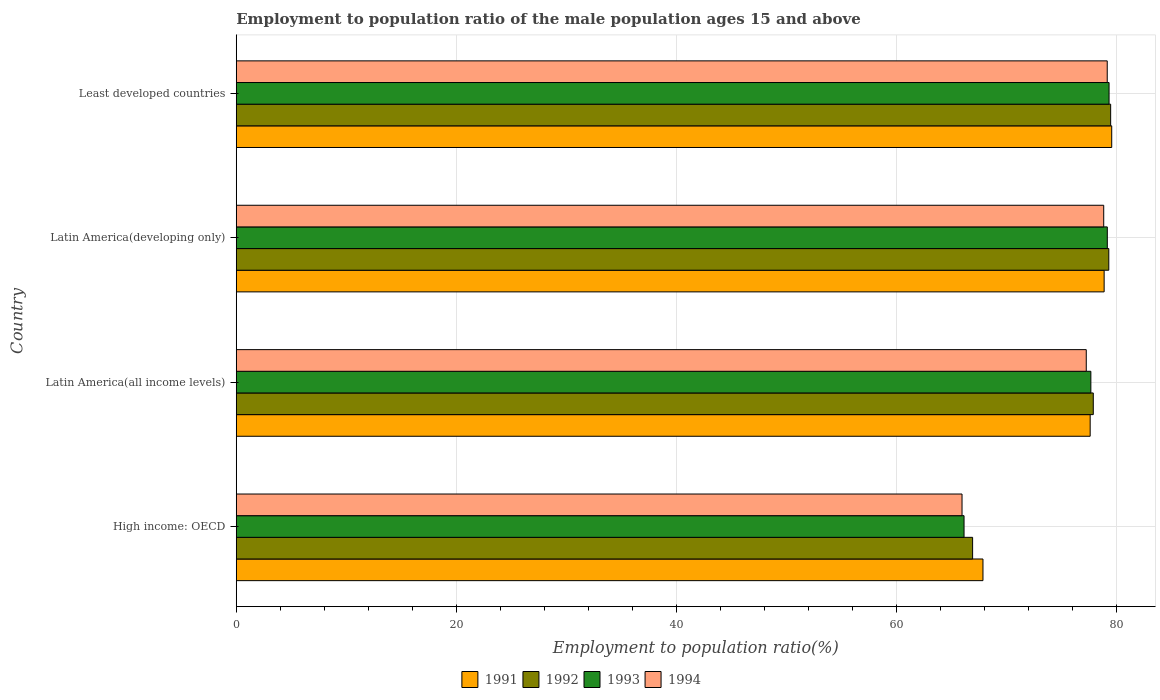How many different coloured bars are there?
Offer a very short reply. 4. How many groups of bars are there?
Ensure brevity in your answer.  4. Are the number of bars per tick equal to the number of legend labels?
Give a very brief answer. Yes. Are the number of bars on each tick of the Y-axis equal?
Provide a succinct answer. Yes. What is the label of the 1st group of bars from the top?
Offer a terse response. Least developed countries. In how many cases, is the number of bars for a given country not equal to the number of legend labels?
Keep it short and to the point. 0. What is the employment to population ratio in 1991 in Latin America(developing only)?
Provide a succinct answer. 78.9. Across all countries, what is the maximum employment to population ratio in 1994?
Offer a very short reply. 79.18. Across all countries, what is the minimum employment to population ratio in 1991?
Your answer should be compact. 67.88. In which country was the employment to population ratio in 1994 maximum?
Offer a very short reply. Least developed countries. In which country was the employment to population ratio in 1994 minimum?
Provide a short and direct response. High income: OECD. What is the total employment to population ratio in 1992 in the graph?
Offer a terse response. 303.66. What is the difference between the employment to population ratio in 1994 in Latin America(developing only) and that in Least developed countries?
Ensure brevity in your answer.  -0.32. What is the difference between the employment to population ratio in 1994 in Latin America(developing only) and the employment to population ratio in 1992 in Least developed countries?
Your answer should be compact. -0.63. What is the average employment to population ratio in 1992 per country?
Provide a short and direct response. 75.92. What is the difference between the employment to population ratio in 1994 and employment to population ratio in 1991 in Least developed countries?
Offer a terse response. -0.41. In how many countries, is the employment to population ratio in 1992 greater than 20 %?
Your answer should be very brief. 4. What is the ratio of the employment to population ratio in 1994 in Latin America(all income levels) to that in Least developed countries?
Ensure brevity in your answer.  0.98. Is the difference between the employment to population ratio in 1994 in Latin America(all income levels) and Latin America(developing only) greater than the difference between the employment to population ratio in 1991 in Latin America(all income levels) and Latin America(developing only)?
Provide a short and direct response. No. What is the difference between the highest and the second highest employment to population ratio in 1991?
Your answer should be very brief. 0.69. What is the difference between the highest and the lowest employment to population ratio in 1992?
Provide a short and direct response. 12.55. In how many countries, is the employment to population ratio in 1991 greater than the average employment to population ratio in 1991 taken over all countries?
Ensure brevity in your answer.  3. Is the sum of the employment to population ratio in 1993 in Latin America(all income levels) and Latin America(developing only) greater than the maximum employment to population ratio in 1991 across all countries?
Your answer should be compact. Yes. What does the 1st bar from the bottom in Latin America(all income levels) represents?
Make the answer very short. 1991. Is it the case that in every country, the sum of the employment to population ratio in 1992 and employment to population ratio in 1993 is greater than the employment to population ratio in 1994?
Give a very brief answer. Yes. How many bars are there?
Give a very brief answer. 16. Are all the bars in the graph horizontal?
Provide a short and direct response. Yes. How many countries are there in the graph?
Give a very brief answer. 4. Does the graph contain any zero values?
Give a very brief answer. No. Does the graph contain grids?
Your answer should be compact. Yes. Where does the legend appear in the graph?
Make the answer very short. Bottom center. How are the legend labels stacked?
Ensure brevity in your answer.  Horizontal. What is the title of the graph?
Offer a very short reply. Employment to population ratio of the male population ages 15 and above. What is the label or title of the X-axis?
Your answer should be very brief. Employment to population ratio(%). What is the label or title of the Y-axis?
Your answer should be compact. Country. What is the Employment to population ratio(%) in 1991 in High income: OECD?
Ensure brevity in your answer.  67.88. What is the Employment to population ratio(%) of 1992 in High income: OECD?
Keep it short and to the point. 66.94. What is the Employment to population ratio(%) in 1993 in High income: OECD?
Your answer should be very brief. 66.16. What is the Employment to population ratio(%) of 1994 in High income: OECD?
Provide a succinct answer. 65.98. What is the Employment to population ratio(%) of 1991 in Latin America(all income levels)?
Provide a short and direct response. 77.63. What is the Employment to population ratio(%) of 1992 in Latin America(all income levels)?
Your response must be concise. 77.91. What is the Employment to population ratio(%) in 1993 in Latin America(all income levels)?
Ensure brevity in your answer.  77.69. What is the Employment to population ratio(%) in 1994 in Latin America(all income levels)?
Provide a short and direct response. 77.27. What is the Employment to population ratio(%) in 1991 in Latin America(developing only)?
Your answer should be very brief. 78.9. What is the Employment to population ratio(%) of 1992 in Latin America(developing only)?
Provide a succinct answer. 79.32. What is the Employment to population ratio(%) in 1993 in Latin America(developing only)?
Make the answer very short. 79.19. What is the Employment to population ratio(%) of 1994 in Latin America(developing only)?
Ensure brevity in your answer.  78.86. What is the Employment to population ratio(%) of 1991 in Least developed countries?
Keep it short and to the point. 79.59. What is the Employment to population ratio(%) in 1992 in Least developed countries?
Your answer should be very brief. 79.49. What is the Employment to population ratio(%) of 1993 in Least developed countries?
Your response must be concise. 79.34. What is the Employment to population ratio(%) of 1994 in Least developed countries?
Your response must be concise. 79.18. Across all countries, what is the maximum Employment to population ratio(%) of 1991?
Your response must be concise. 79.59. Across all countries, what is the maximum Employment to population ratio(%) of 1992?
Ensure brevity in your answer.  79.49. Across all countries, what is the maximum Employment to population ratio(%) in 1993?
Provide a succinct answer. 79.34. Across all countries, what is the maximum Employment to population ratio(%) of 1994?
Provide a short and direct response. 79.18. Across all countries, what is the minimum Employment to population ratio(%) in 1991?
Your answer should be compact. 67.88. Across all countries, what is the minimum Employment to population ratio(%) of 1992?
Offer a very short reply. 66.94. Across all countries, what is the minimum Employment to population ratio(%) in 1993?
Provide a short and direct response. 66.16. Across all countries, what is the minimum Employment to population ratio(%) of 1994?
Your response must be concise. 65.98. What is the total Employment to population ratio(%) of 1991 in the graph?
Give a very brief answer. 303.99. What is the total Employment to population ratio(%) of 1992 in the graph?
Your response must be concise. 303.66. What is the total Employment to population ratio(%) of 1993 in the graph?
Offer a very short reply. 302.38. What is the total Employment to population ratio(%) of 1994 in the graph?
Give a very brief answer. 301.29. What is the difference between the Employment to population ratio(%) in 1991 in High income: OECD and that in Latin America(all income levels)?
Keep it short and to the point. -9.75. What is the difference between the Employment to population ratio(%) in 1992 in High income: OECD and that in Latin America(all income levels)?
Your answer should be compact. -10.97. What is the difference between the Employment to population ratio(%) in 1993 in High income: OECD and that in Latin America(all income levels)?
Provide a succinct answer. -11.53. What is the difference between the Employment to population ratio(%) in 1994 in High income: OECD and that in Latin America(all income levels)?
Make the answer very short. -11.29. What is the difference between the Employment to population ratio(%) in 1991 in High income: OECD and that in Latin America(developing only)?
Your response must be concise. -11.02. What is the difference between the Employment to population ratio(%) of 1992 in High income: OECD and that in Latin America(developing only)?
Offer a terse response. -12.38. What is the difference between the Employment to population ratio(%) of 1993 in High income: OECD and that in Latin America(developing only)?
Make the answer very short. -13.02. What is the difference between the Employment to population ratio(%) of 1994 in High income: OECD and that in Latin America(developing only)?
Provide a succinct answer. -12.88. What is the difference between the Employment to population ratio(%) in 1991 in High income: OECD and that in Least developed countries?
Make the answer very short. -11.7. What is the difference between the Employment to population ratio(%) of 1992 in High income: OECD and that in Least developed countries?
Give a very brief answer. -12.55. What is the difference between the Employment to population ratio(%) of 1993 in High income: OECD and that in Least developed countries?
Give a very brief answer. -13.18. What is the difference between the Employment to population ratio(%) in 1994 in High income: OECD and that in Least developed countries?
Your answer should be very brief. -13.2. What is the difference between the Employment to population ratio(%) of 1991 in Latin America(all income levels) and that in Latin America(developing only)?
Ensure brevity in your answer.  -1.27. What is the difference between the Employment to population ratio(%) of 1992 in Latin America(all income levels) and that in Latin America(developing only)?
Keep it short and to the point. -1.41. What is the difference between the Employment to population ratio(%) of 1993 in Latin America(all income levels) and that in Latin America(developing only)?
Make the answer very short. -1.49. What is the difference between the Employment to population ratio(%) of 1994 in Latin America(all income levels) and that in Latin America(developing only)?
Give a very brief answer. -1.59. What is the difference between the Employment to population ratio(%) in 1991 in Latin America(all income levels) and that in Least developed countries?
Offer a terse response. -1.96. What is the difference between the Employment to population ratio(%) of 1992 in Latin America(all income levels) and that in Least developed countries?
Provide a short and direct response. -1.58. What is the difference between the Employment to population ratio(%) of 1993 in Latin America(all income levels) and that in Least developed countries?
Your response must be concise. -1.65. What is the difference between the Employment to population ratio(%) of 1994 in Latin America(all income levels) and that in Least developed countries?
Keep it short and to the point. -1.91. What is the difference between the Employment to population ratio(%) in 1991 in Latin America(developing only) and that in Least developed countries?
Provide a succinct answer. -0.69. What is the difference between the Employment to population ratio(%) in 1992 in Latin America(developing only) and that in Least developed countries?
Make the answer very short. -0.17. What is the difference between the Employment to population ratio(%) in 1993 in Latin America(developing only) and that in Least developed countries?
Make the answer very short. -0.16. What is the difference between the Employment to population ratio(%) in 1994 in Latin America(developing only) and that in Least developed countries?
Make the answer very short. -0.32. What is the difference between the Employment to population ratio(%) in 1991 in High income: OECD and the Employment to population ratio(%) in 1992 in Latin America(all income levels)?
Provide a short and direct response. -10.03. What is the difference between the Employment to population ratio(%) of 1991 in High income: OECD and the Employment to population ratio(%) of 1993 in Latin America(all income levels)?
Provide a succinct answer. -9.81. What is the difference between the Employment to population ratio(%) in 1991 in High income: OECD and the Employment to population ratio(%) in 1994 in Latin America(all income levels)?
Provide a succinct answer. -9.39. What is the difference between the Employment to population ratio(%) of 1992 in High income: OECD and the Employment to population ratio(%) of 1993 in Latin America(all income levels)?
Provide a short and direct response. -10.75. What is the difference between the Employment to population ratio(%) in 1992 in High income: OECD and the Employment to population ratio(%) in 1994 in Latin America(all income levels)?
Provide a succinct answer. -10.33. What is the difference between the Employment to population ratio(%) of 1993 in High income: OECD and the Employment to population ratio(%) of 1994 in Latin America(all income levels)?
Offer a very short reply. -11.11. What is the difference between the Employment to population ratio(%) in 1991 in High income: OECD and the Employment to population ratio(%) in 1992 in Latin America(developing only)?
Provide a succinct answer. -11.44. What is the difference between the Employment to population ratio(%) of 1991 in High income: OECD and the Employment to population ratio(%) of 1993 in Latin America(developing only)?
Offer a very short reply. -11.3. What is the difference between the Employment to population ratio(%) of 1991 in High income: OECD and the Employment to population ratio(%) of 1994 in Latin America(developing only)?
Your answer should be compact. -10.98. What is the difference between the Employment to population ratio(%) in 1992 in High income: OECD and the Employment to population ratio(%) in 1993 in Latin America(developing only)?
Your answer should be compact. -12.25. What is the difference between the Employment to population ratio(%) in 1992 in High income: OECD and the Employment to population ratio(%) in 1994 in Latin America(developing only)?
Make the answer very short. -11.92. What is the difference between the Employment to population ratio(%) of 1993 in High income: OECD and the Employment to population ratio(%) of 1994 in Latin America(developing only)?
Give a very brief answer. -12.7. What is the difference between the Employment to population ratio(%) in 1991 in High income: OECD and the Employment to population ratio(%) in 1992 in Least developed countries?
Your response must be concise. -11.61. What is the difference between the Employment to population ratio(%) of 1991 in High income: OECD and the Employment to population ratio(%) of 1993 in Least developed countries?
Provide a succinct answer. -11.46. What is the difference between the Employment to population ratio(%) of 1991 in High income: OECD and the Employment to population ratio(%) of 1994 in Least developed countries?
Your answer should be compact. -11.3. What is the difference between the Employment to population ratio(%) of 1992 in High income: OECD and the Employment to population ratio(%) of 1993 in Least developed countries?
Provide a short and direct response. -12.4. What is the difference between the Employment to population ratio(%) of 1992 in High income: OECD and the Employment to population ratio(%) of 1994 in Least developed countries?
Keep it short and to the point. -12.24. What is the difference between the Employment to population ratio(%) in 1993 in High income: OECD and the Employment to population ratio(%) in 1994 in Least developed countries?
Ensure brevity in your answer.  -13.02. What is the difference between the Employment to population ratio(%) of 1991 in Latin America(all income levels) and the Employment to population ratio(%) of 1992 in Latin America(developing only)?
Keep it short and to the point. -1.69. What is the difference between the Employment to population ratio(%) in 1991 in Latin America(all income levels) and the Employment to population ratio(%) in 1993 in Latin America(developing only)?
Keep it short and to the point. -1.56. What is the difference between the Employment to population ratio(%) of 1991 in Latin America(all income levels) and the Employment to population ratio(%) of 1994 in Latin America(developing only)?
Ensure brevity in your answer.  -1.23. What is the difference between the Employment to population ratio(%) in 1992 in Latin America(all income levels) and the Employment to population ratio(%) in 1993 in Latin America(developing only)?
Ensure brevity in your answer.  -1.28. What is the difference between the Employment to population ratio(%) of 1992 in Latin America(all income levels) and the Employment to population ratio(%) of 1994 in Latin America(developing only)?
Offer a very short reply. -0.95. What is the difference between the Employment to population ratio(%) of 1993 in Latin America(all income levels) and the Employment to population ratio(%) of 1994 in Latin America(developing only)?
Your answer should be very brief. -1.17. What is the difference between the Employment to population ratio(%) of 1991 in Latin America(all income levels) and the Employment to population ratio(%) of 1992 in Least developed countries?
Make the answer very short. -1.86. What is the difference between the Employment to population ratio(%) of 1991 in Latin America(all income levels) and the Employment to population ratio(%) of 1993 in Least developed countries?
Your response must be concise. -1.72. What is the difference between the Employment to population ratio(%) in 1991 in Latin America(all income levels) and the Employment to population ratio(%) in 1994 in Least developed countries?
Ensure brevity in your answer.  -1.55. What is the difference between the Employment to population ratio(%) in 1992 in Latin America(all income levels) and the Employment to population ratio(%) in 1993 in Least developed countries?
Offer a terse response. -1.44. What is the difference between the Employment to population ratio(%) of 1992 in Latin America(all income levels) and the Employment to population ratio(%) of 1994 in Least developed countries?
Keep it short and to the point. -1.27. What is the difference between the Employment to population ratio(%) in 1993 in Latin America(all income levels) and the Employment to population ratio(%) in 1994 in Least developed countries?
Provide a succinct answer. -1.49. What is the difference between the Employment to population ratio(%) of 1991 in Latin America(developing only) and the Employment to population ratio(%) of 1992 in Least developed countries?
Your answer should be very brief. -0.59. What is the difference between the Employment to population ratio(%) of 1991 in Latin America(developing only) and the Employment to population ratio(%) of 1993 in Least developed countries?
Offer a terse response. -0.45. What is the difference between the Employment to population ratio(%) of 1991 in Latin America(developing only) and the Employment to population ratio(%) of 1994 in Least developed countries?
Provide a short and direct response. -0.28. What is the difference between the Employment to population ratio(%) of 1992 in Latin America(developing only) and the Employment to population ratio(%) of 1993 in Least developed countries?
Ensure brevity in your answer.  -0.02. What is the difference between the Employment to population ratio(%) in 1992 in Latin America(developing only) and the Employment to population ratio(%) in 1994 in Least developed countries?
Ensure brevity in your answer.  0.14. What is the difference between the Employment to population ratio(%) of 1993 in Latin America(developing only) and the Employment to population ratio(%) of 1994 in Least developed countries?
Your response must be concise. 0.01. What is the average Employment to population ratio(%) of 1991 per country?
Your answer should be very brief. 76. What is the average Employment to population ratio(%) in 1992 per country?
Provide a succinct answer. 75.92. What is the average Employment to population ratio(%) of 1993 per country?
Offer a very short reply. 75.6. What is the average Employment to population ratio(%) of 1994 per country?
Your answer should be compact. 75.32. What is the difference between the Employment to population ratio(%) of 1991 and Employment to population ratio(%) of 1992 in High income: OECD?
Offer a terse response. 0.94. What is the difference between the Employment to population ratio(%) in 1991 and Employment to population ratio(%) in 1993 in High income: OECD?
Your answer should be very brief. 1.72. What is the difference between the Employment to population ratio(%) in 1991 and Employment to population ratio(%) in 1994 in High income: OECD?
Your response must be concise. 1.9. What is the difference between the Employment to population ratio(%) of 1992 and Employment to population ratio(%) of 1993 in High income: OECD?
Your answer should be compact. 0.78. What is the difference between the Employment to population ratio(%) of 1992 and Employment to population ratio(%) of 1994 in High income: OECD?
Your response must be concise. 0.96. What is the difference between the Employment to population ratio(%) in 1993 and Employment to population ratio(%) in 1994 in High income: OECD?
Make the answer very short. 0.18. What is the difference between the Employment to population ratio(%) of 1991 and Employment to population ratio(%) of 1992 in Latin America(all income levels)?
Your answer should be very brief. -0.28. What is the difference between the Employment to population ratio(%) in 1991 and Employment to population ratio(%) in 1993 in Latin America(all income levels)?
Provide a succinct answer. -0.06. What is the difference between the Employment to population ratio(%) of 1991 and Employment to population ratio(%) of 1994 in Latin America(all income levels)?
Keep it short and to the point. 0.36. What is the difference between the Employment to population ratio(%) of 1992 and Employment to population ratio(%) of 1993 in Latin America(all income levels)?
Keep it short and to the point. 0.22. What is the difference between the Employment to population ratio(%) of 1992 and Employment to population ratio(%) of 1994 in Latin America(all income levels)?
Provide a short and direct response. 0.64. What is the difference between the Employment to population ratio(%) in 1993 and Employment to population ratio(%) in 1994 in Latin America(all income levels)?
Offer a very short reply. 0.42. What is the difference between the Employment to population ratio(%) in 1991 and Employment to population ratio(%) in 1992 in Latin America(developing only)?
Ensure brevity in your answer.  -0.42. What is the difference between the Employment to population ratio(%) in 1991 and Employment to population ratio(%) in 1993 in Latin America(developing only)?
Offer a terse response. -0.29. What is the difference between the Employment to population ratio(%) of 1991 and Employment to population ratio(%) of 1994 in Latin America(developing only)?
Keep it short and to the point. 0.04. What is the difference between the Employment to population ratio(%) in 1992 and Employment to population ratio(%) in 1993 in Latin America(developing only)?
Ensure brevity in your answer.  0.14. What is the difference between the Employment to population ratio(%) of 1992 and Employment to population ratio(%) of 1994 in Latin America(developing only)?
Your answer should be very brief. 0.46. What is the difference between the Employment to population ratio(%) in 1993 and Employment to population ratio(%) in 1994 in Latin America(developing only)?
Ensure brevity in your answer.  0.33. What is the difference between the Employment to population ratio(%) in 1991 and Employment to population ratio(%) in 1992 in Least developed countries?
Provide a short and direct response. 0.1. What is the difference between the Employment to population ratio(%) of 1991 and Employment to population ratio(%) of 1993 in Least developed countries?
Make the answer very short. 0.24. What is the difference between the Employment to population ratio(%) of 1991 and Employment to population ratio(%) of 1994 in Least developed countries?
Offer a terse response. 0.41. What is the difference between the Employment to population ratio(%) in 1992 and Employment to population ratio(%) in 1993 in Least developed countries?
Your response must be concise. 0.15. What is the difference between the Employment to population ratio(%) of 1992 and Employment to population ratio(%) of 1994 in Least developed countries?
Provide a succinct answer. 0.31. What is the difference between the Employment to population ratio(%) in 1993 and Employment to population ratio(%) in 1994 in Least developed countries?
Provide a succinct answer. 0.17. What is the ratio of the Employment to population ratio(%) of 1991 in High income: OECD to that in Latin America(all income levels)?
Your answer should be compact. 0.87. What is the ratio of the Employment to population ratio(%) of 1992 in High income: OECD to that in Latin America(all income levels)?
Your answer should be very brief. 0.86. What is the ratio of the Employment to population ratio(%) in 1993 in High income: OECD to that in Latin America(all income levels)?
Provide a short and direct response. 0.85. What is the ratio of the Employment to population ratio(%) of 1994 in High income: OECD to that in Latin America(all income levels)?
Your response must be concise. 0.85. What is the ratio of the Employment to population ratio(%) of 1991 in High income: OECD to that in Latin America(developing only)?
Provide a short and direct response. 0.86. What is the ratio of the Employment to population ratio(%) in 1992 in High income: OECD to that in Latin America(developing only)?
Your answer should be very brief. 0.84. What is the ratio of the Employment to population ratio(%) in 1993 in High income: OECD to that in Latin America(developing only)?
Offer a terse response. 0.84. What is the ratio of the Employment to population ratio(%) in 1994 in High income: OECD to that in Latin America(developing only)?
Ensure brevity in your answer.  0.84. What is the ratio of the Employment to population ratio(%) in 1991 in High income: OECD to that in Least developed countries?
Offer a terse response. 0.85. What is the ratio of the Employment to population ratio(%) of 1992 in High income: OECD to that in Least developed countries?
Your answer should be compact. 0.84. What is the ratio of the Employment to population ratio(%) in 1993 in High income: OECD to that in Least developed countries?
Ensure brevity in your answer.  0.83. What is the ratio of the Employment to population ratio(%) of 1991 in Latin America(all income levels) to that in Latin America(developing only)?
Give a very brief answer. 0.98. What is the ratio of the Employment to population ratio(%) in 1992 in Latin America(all income levels) to that in Latin America(developing only)?
Provide a short and direct response. 0.98. What is the ratio of the Employment to population ratio(%) of 1993 in Latin America(all income levels) to that in Latin America(developing only)?
Give a very brief answer. 0.98. What is the ratio of the Employment to population ratio(%) of 1994 in Latin America(all income levels) to that in Latin America(developing only)?
Your answer should be very brief. 0.98. What is the ratio of the Employment to population ratio(%) of 1991 in Latin America(all income levels) to that in Least developed countries?
Provide a succinct answer. 0.98. What is the ratio of the Employment to population ratio(%) of 1992 in Latin America(all income levels) to that in Least developed countries?
Offer a terse response. 0.98. What is the ratio of the Employment to population ratio(%) of 1993 in Latin America(all income levels) to that in Least developed countries?
Make the answer very short. 0.98. What is the ratio of the Employment to population ratio(%) of 1994 in Latin America(all income levels) to that in Least developed countries?
Your answer should be compact. 0.98. What is the ratio of the Employment to population ratio(%) in 1992 in Latin America(developing only) to that in Least developed countries?
Give a very brief answer. 1. What is the difference between the highest and the second highest Employment to population ratio(%) of 1991?
Your answer should be very brief. 0.69. What is the difference between the highest and the second highest Employment to population ratio(%) of 1992?
Provide a short and direct response. 0.17. What is the difference between the highest and the second highest Employment to population ratio(%) of 1993?
Provide a short and direct response. 0.16. What is the difference between the highest and the second highest Employment to population ratio(%) in 1994?
Your answer should be very brief. 0.32. What is the difference between the highest and the lowest Employment to population ratio(%) of 1991?
Offer a terse response. 11.7. What is the difference between the highest and the lowest Employment to population ratio(%) in 1992?
Provide a short and direct response. 12.55. What is the difference between the highest and the lowest Employment to population ratio(%) of 1993?
Your answer should be very brief. 13.18. What is the difference between the highest and the lowest Employment to population ratio(%) in 1994?
Ensure brevity in your answer.  13.2. 